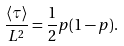<formula> <loc_0><loc_0><loc_500><loc_500>\frac { \langle \tau \rangle } { L ^ { 2 } } = \frac { 1 } { 2 } p ( 1 - p ) .</formula> 